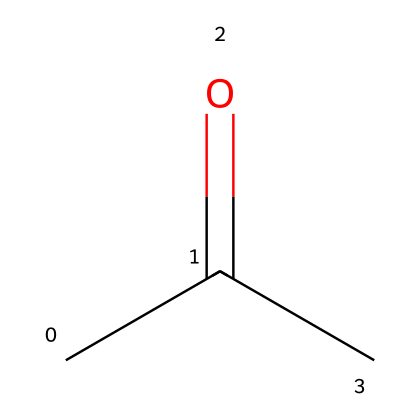What is the molecular formula of this compound? The SMILES representation "CC(=O)C" indicates that the compound has three carbon atoms (C), six hydrogen atoms (H), and one oxygen atom (O), which gives the molecular formula C3H6O.
Answer: C3H6O How many hydrogen atoms are in this molecule? Count the hydrogen atoms in the SMILES representation. There are six hydrogen atoms represented alongside the three carbon atoms and one oxygen.
Answer: 6 What type of functional group is present in acetone? The presence of the =O bond in the SMILES indicates a carbonyl functional group, specifically a ketone, which distinguishes acetone from other types of carbonyl compounds like aldehydes.
Answer: ketone What is the boiling point of acetone? Acetone typically has a boiling point around 56 degrees Celsius, which can be deduced from known properties of ketones as well as safety data sheets.
Answer: 56 Is acetone considered a flammable liquid? Acetone is known to have a low flash point (around 20 degrees Celsius), classifying it as a flammable liquid and posing risks if exposed to heat or flames.
Answer: yes How many double bonds are present in this molecule? Analyzing the SMILES representation, the presence of the =O indicates one double bond between carbon and oxygen, while all other bonds are single, resulting in a total of one double bond.
Answer: 1 